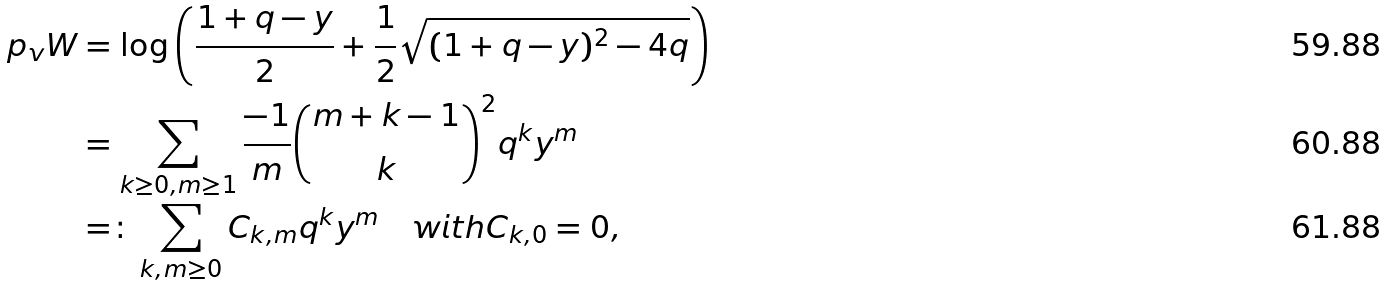Convert formula to latex. <formula><loc_0><loc_0><loc_500><loc_500>\ p _ { v } W & = \log \left ( \frac { 1 + q - y } { 2 } + \frac { 1 } { 2 } \sqrt { ( 1 + q - y ) ^ { 2 } - 4 q } \right ) \\ & = \sum _ { k \geq 0 , m \geq 1 } \frac { - 1 } { m } { m + k - 1 \choose k } ^ { 2 } q ^ { k } y ^ { m } \\ & = \colon \sum _ { k , m \geq 0 } C _ { k , m } q ^ { k } y ^ { m } \quad w i t h C _ { k , 0 } = 0 ,</formula> 